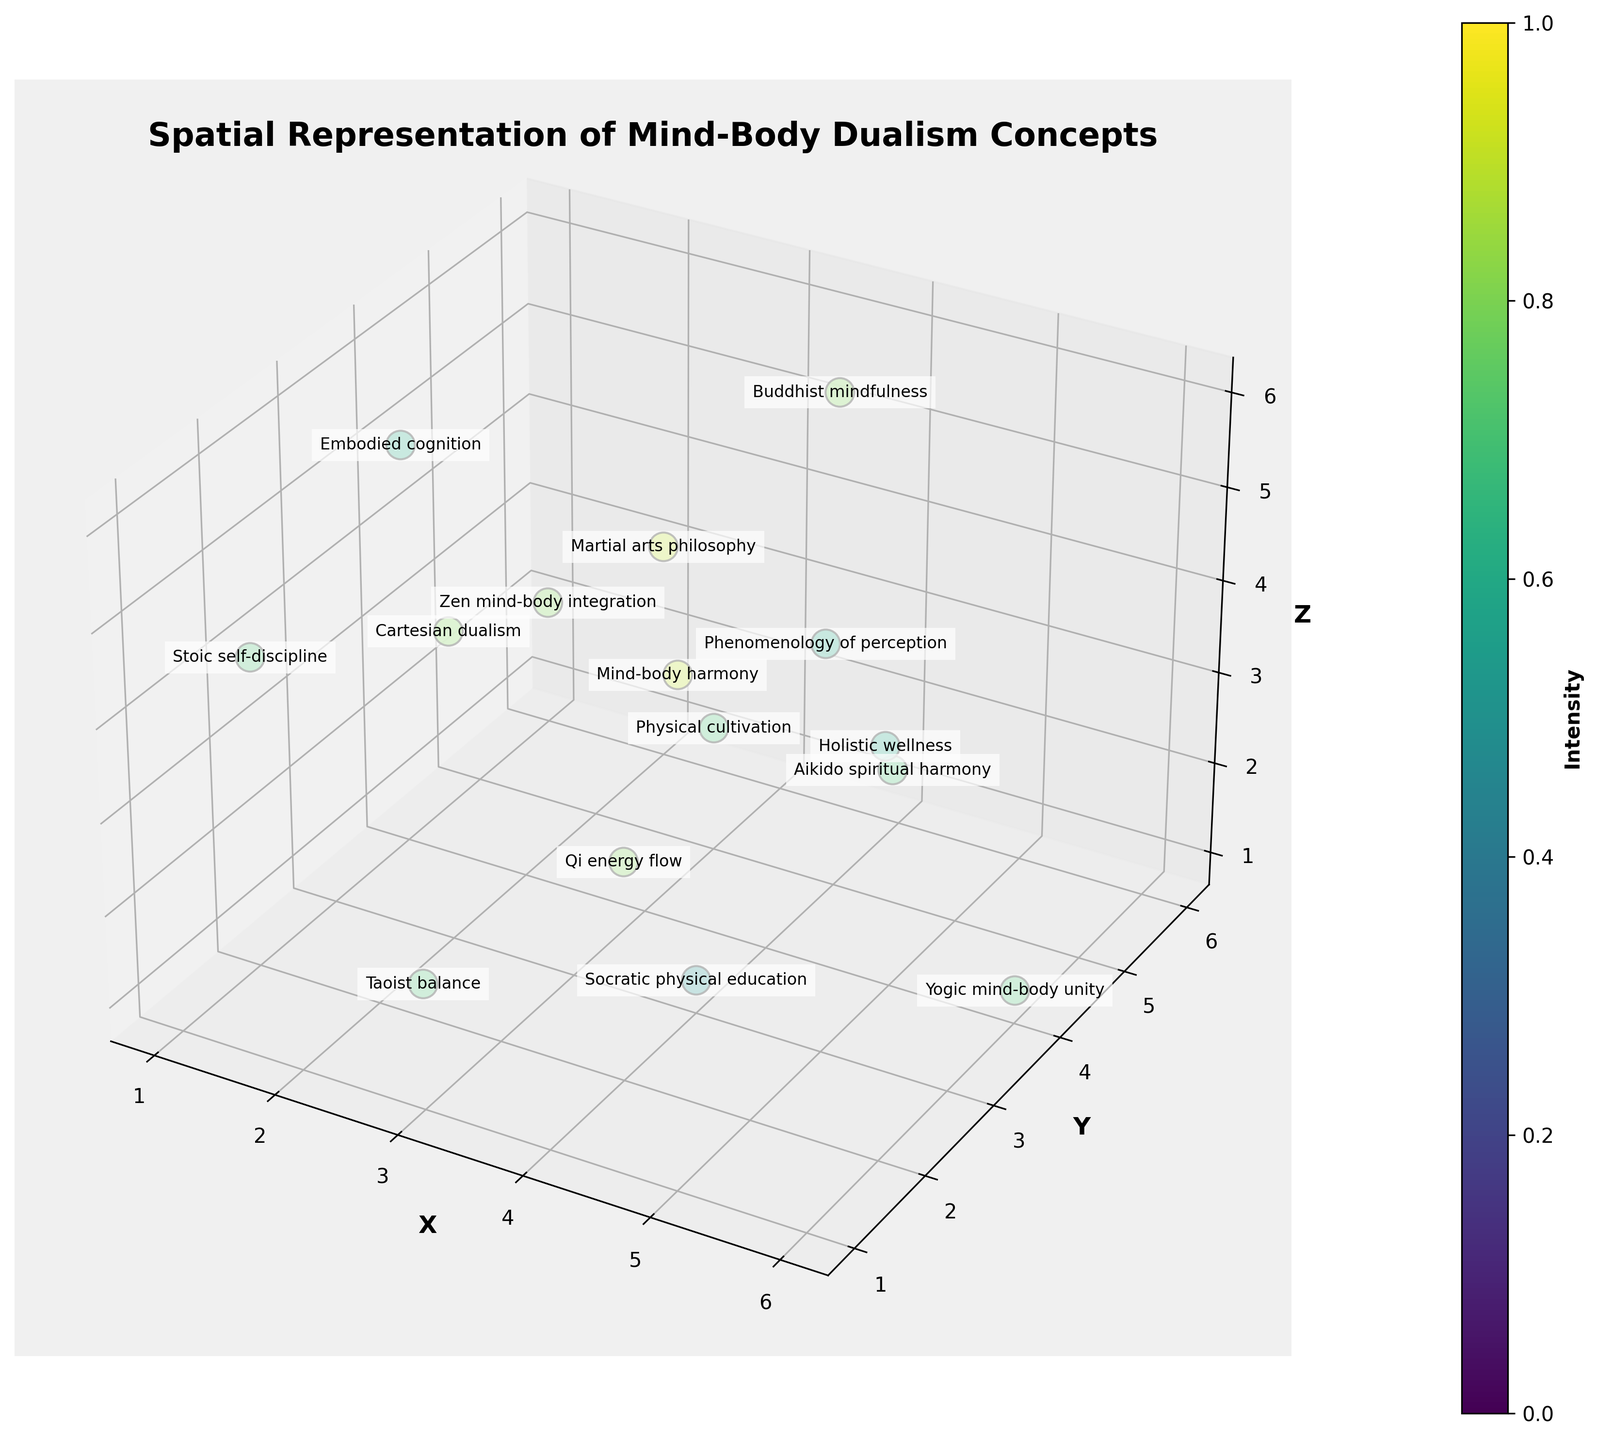How many data points represent Eastern culture? First, look for the data points labeled as "Eastern" in the figure. There is only one data point labeled "Mind-body harmony" categorized under Eastern.
Answer: 1 What is the title of the plot? The plot's title is usually located at the top of the figure. From the provided description, it is "Spatial Representation of Mind-Body Dualism Concepts."
Answer: Spatial Representation of Mind-Body Dualism Concepts Which culture has the highest intensity value in the figure? Identify the data points with the highest intensity value. The highest intensity value is 0.9, and it is represented by the Eastern and Japanese cultures. The concepts are "Mind-body harmony" (Eastern) and "Martial arts philosophy" (Japanese).
Answer: Eastern, Japanese What is the average intensity value of the concepts represented in Western and Ancient Greek cultures? First, identify the intensity values of Western and Ancient Greek cultures: Western (0.8) and Ancient Greek (0.7, 0.5). Sum the intensity values: 0.8 + 0.7 + 0.5 = 2.0. There are 3 values total, so the average is 2.0 / 3 = 0.67.
Answer: 0.67 Which culture is depicted at coordinates (4, 5, 6)? Locate the data point at coordinates (4, 5, 6). The culture depicted at these coordinates is Tibetan, representing the concept "Buddhist mindfulness."
Answer: Tibetan Compare the intensity values of Cartesian dualism and Zen mind-body integration. Which is higher? Identify the intensity values for both concepts: Cartesian dualism (0.8) and Zen mind-body integration (0.8). Both concepts have the same intensity value.
Answer: Equal What is the most frequent intensity value among all data points? List all intensity values and determine the frequency of each: (0.8, 0.9, 0.7, 0.6, 0.8, 0.7, 0.9, 0.6, 0.7, 0.8, 0.7, 0.6, 0.5, 0.8, 0.7). The intensity value 0.8 occurs most frequently, with a total of four occurrences.
Answer: 0.8 What concept is represented at the coordinates (3, 1, 2)? Look at the data point located at coordinates (3, 1, 2). The concept at this location is "Taoist balance."
Answer: Taoist balance 